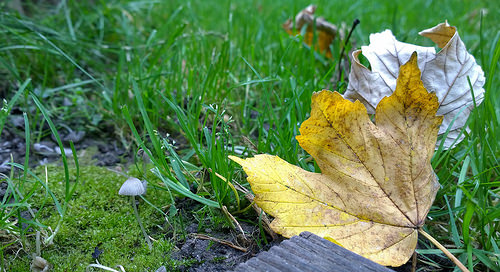<image>
Is there a leave behind the leave? Yes. From this viewpoint, the leave is positioned behind the leave, with the leave partially or fully occluding the leave. Is there a grass on the leaf? No. The grass is not positioned on the leaf. They may be near each other, but the grass is not supported by or resting on top of the leaf. 